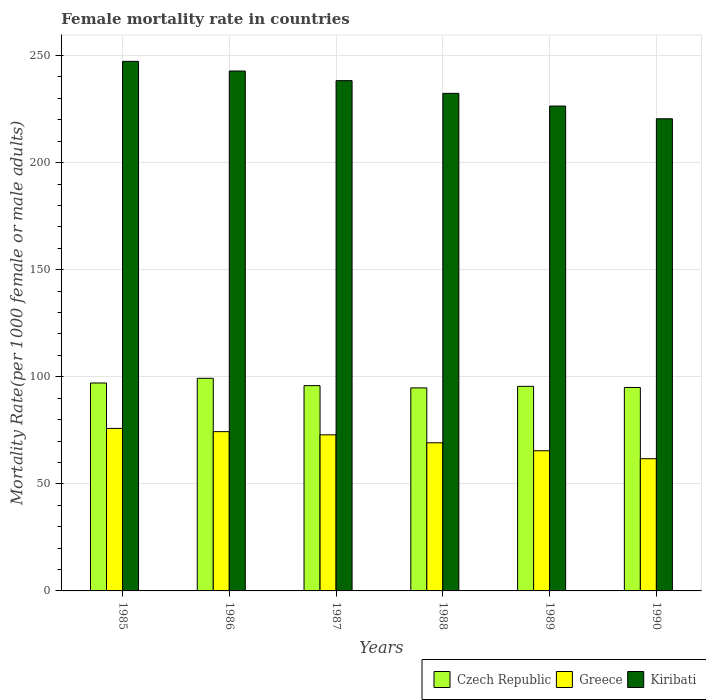How many different coloured bars are there?
Provide a succinct answer. 3. How many groups of bars are there?
Provide a short and direct response. 6. How many bars are there on the 4th tick from the left?
Your answer should be compact. 3. How many bars are there on the 3rd tick from the right?
Offer a terse response. 3. What is the female mortality rate in Greece in 1990?
Provide a succinct answer. 61.74. Across all years, what is the maximum female mortality rate in Kiribati?
Ensure brevity in your answer.  247.28. Across all years, what is the minimum female mortality rate in Greece?
Your answer should be very brief. 61.74. In which year was the female mortality rate in Greece maximum?
Offer a terse response. 1985. In which year was the female mortality rate in Kiribati minimum?
Offer a very short reply. 1990. What is the total female mortality rate in Greece in the graph?
Offer a very short reply. 419.49. What is the difference between the female mortality rate in Czech Republic in 1987 and that in 1989?
Give a very brief answer. 0.33. What is the difference between the female mortality rate in Czech Republic in 1988 and the female mortality rate in Kiribati in 1990?
Make the answer very short. -125.67. What is the average female mortality rate in Greece per year?
Offer a very short reply. 69.91. In the year 1985, what is the difference between the female mortality rate in Czech Republic and female mortality rate in Kiribati?
Your answer should be very brief. -150.19. What is the ratio of the female mortality rate in Greece in 1986 to that in 1989?
Offer a very short reply. 1.14. Is the female mortality rate in Greece in 1985 less than that in 1988?
Give a very brief answer. No. What is the difference between the highest and the second highest female mortality rate in Kiribati?
Offer a very short reply. 4.51. What is the difference between the highest and the lowest female mortality rate in Greece?
Offer a terse response. 14.14. In how many years, is the female mortality rate in Kiribati greater than the average female mortality rate in Kiribati taken over all years?
Your answer should be very brief. 3. Is the sum of the female mortality rate in Czech Republic in 1987 and 1990 greater than the maximum female mortality rate in Greece across all years?
Offer a terse response. Yes. What does the 3rd bar from the right in 1987 represents?
Offer a terse response. Czech Republic. Is it the case that in every year, the sum of the female mortality rate in Czech Republic and female mortality rate in Kiribati is greater than the female mortality rate in Greece?
Keep it short and to the point. Yes. How many bars are there?
Ensure brevity in your answer.  18. Are all the bars in the graph horizontal?
Your answer should be compact. No. How many years are there in the graph?
Offer a terse response. 6. What is the difference between two consecutive major ticks on the Y-axis?
Offer a terse response. 50. Are the values on the major ticks of Y-axis written in scientific E-notation?
Your response must be concise. No. Does the graph contain any zero values?
Give a very brief answer. No. Does the graph contain grids?
Provide a short and direct response. Yes. How are the legend labels stacked?
Provide a succinct answer. Horizontal. What is the title of the graph?
Your answer should be very brief. Female mortality rate in countries. Does "Cayman Islands" appear as one of the legend labels in the graph?
Provide a short and direct response. No. What is the label or title of the X-axis?
Give a very brief answer. Years. What is the label or title of the Y-axis?
Ensure brevity in your answer.  Mortality Rate(per 1000 female or male adults). What is the Mortality Rate(per 1000 female or male adults) of Czech Republic in 1985?
Keep it short and to the point. 97.09. What is the Mortality Rate(per 1000 female or male adults) of Greece in 1985?
Your answer should be very brief. 75.88. What is the Mortality Rate(per 1000 female or male adults) in Kiribati in 1985?
Give a very brief answer. 247.28. What is the Mortality Rate(per 1000 female or male adults) of Czech Republic in 1986?
Ensure brevity in your answer.  99.28. What is the Mortality Rate(per 1000 female or male adults) in Greece in 1986?
Make the answer very short. 74.38. What is the Mortality Rate(per 1000 female or male adults) in Kiribati in 1986?
Ensure brevity in your answer.  242.77. What is the Mortality Rate(per 1000 female or male adults) in Czech Republic in 1987?
Your answer should be very brief. 95.85. What is the Mortality Rate(per 1000 female or male adults) of Greece in 1987?
Provide a succinct answer. 72.88. What is the Mortality Rate(per 1000 female or male adults) in Kiribati in 1987?
Offer a very short reply. 238.26. What is the Mortality Rate(per 1000 female or male adults) in Czech Republic in 1988?
Offer a very short reply. 94.8. What is the Mortality Rate(per 1000 female or male adults) of Greece in 1988?
Ensure brevity in your answer.  69.17. What is the Mortality Rate(per 1000 female or male adults) in Kiribati in 1988?
Ensure brevity in your answer.  232.33. What is the Mortality Rate(per 1000 female or male adults) of Czech Republic in 1989?
Offer a very short reply. 95.52. What is the Mortality Rate(per 1000 female or male adults) of Greece in 1989?
Keep it short and to the point. 65.45. What is the Mortality Rate(per 1000 female or male adults) of Kiribati in 1989?
Give a very brief answer. 226.4. What is the Mortality Rate(per 1000 female or male adults) in Czech Republic in 1990?
Offer a very short reply. 95.01. What is the Mortality Rate(per 1000 female or male adults) of Greece in 1990?
Give a very brief answer. 61.74. What is the Mortality Rate(per 1000 female or male adults) of Kiribati in 1990?
Give a very brief answer. 220.47. Across all years, what is the maximum Mortality Rate(per 1000 female or male adults) in Czech Republic?
Ensure brevity in your answer.  99.28. Across all years, what is the maximum Mortality Rate(per 1000 female or male adults) in Greece?
Ensure brevity in your answer.  75.88. Across all years, what is the maximum Mortality Rate(per 1000 female or male adults) of Kiribati?
Offer a very short reply. 247.28. Across all years, what is the minimum Mortality Rate(per 1000 female or male adults) of Czech Republic?
Offer a terse response. 94.8. Across all years, what is the minimum Mortality Rate(per 1000 female or male adults) of Greece?
Your response must be concise. 61.74. Across all years, what is the minimum Mortality Rate(per 1000 female or male adults) in Kiribati?
Ensure brevity in your answer.  220.47. What is the total Mortality Rate(per 1000 female or male adults) in Czech Republic in the graph?
Offer a terse response. 577.55. What is the total Mortality Rate(per 1000 female or male adults) in Greece in the graph?
Offer a very short reply. 419.49. What is the total Mortality Rate(per 1000 female or male adults) of Kiribati in the graph?
Your answer should be very brief. 1407.51. What is the difference between the Mortality Rate(per 1000 female or male adults) in Czech Republic in 1985 and that in 1986?
Provide a succinct answer. -2.19. What is the difference between the Mortality Rate(per 1000 female or male adults) in Greece in 1985 and that in 1986?
Keep it short and to the point. 1.5. What is the difference between the Mortality Rate(per 1000 female or male adults) in Kiribati in 1985 and that in 1986?
Give a very brief answer. 4.51. What is the difference between the Mortality Rate(per 1000 female or male adults) of Czech Republic in 1985 and that in 1987?
Give a very brief answer. 1.23. What is the difference between the Mortality Rate(per 1000 female or male adults) of Greece in 1985 and that in 1987?
Your response must be concise. 3. What is the difference between the Mortality Rate(per 1000 female or male adults) in Kiribati in 1985 and that in 1987?
Your answer should be very brief. 9.01. What is the difference between the Mortality Rate(per 1000 female or male adults) of Czech Republic in 1985 and that in 1988?
Make the answer very short. 2.29. What is the difference between the Mortality Rate(per 1000 female or male adults) in Greece in 1985 and that in 1988?
Provide a short and direct response. 6.71. What is the difference between the Mortality Rate(per 1000 female or male adults) of Kiribati in 1985 and that in 1988?
Ensure brevity in your answer.  14.94. What is the difference between the Mortality Rate(per 1000 female or male adults) in Czech Republic in 1985 and that in 1989?
Your answer should be very brief. 1.56. What is the difference between the Mortality Rate(per 1000 female or male adults) of Greece in 1985 and that in 1989?
Offer a very short reply. 10.43. What is the difference between the Mortality Rate(per 1000 female or male adults) of Kiribati in 1985 and that in 1989?
Offer a very short reply. 20.88. What is the difference between the Mortality Rate(per 1000 female or male adults) in Czech Republic in 1985 and that in 1990?
Ensure brevity in your answer.  2.08. What is the difference between the Mortality Rate(per 1000 female or male adults) of Greece in 1985 and that in 1990?
Give a very brief answer. 14.14. What is the difference between the Mortality Rate(per 1000 female or male adults) in Kiribati in 1985 and that in 1990?
Provide a short and direct response. 26.81. What is the difference between the Mortality Rate(per 1000 female or male adults) in Czech Republic in 1986 and that in 1987?
Give a very brief answer. 3.43. What is the difference between the Mortality Rate(per 1000 female or male adults) of Greece in 1986 and that in 1987?
Provide a succinct answer. 1.5. What is the difference between the Mortality Rate(per 1000 female or male adults) in Kiribati in 1986 and that in 1987?
Give a very brief answer. 4.51. What is the difference between the Mortality Rate(per 1000 female or male adults) in Czech Republic in 1986 and that in 1988?
Make the answer very short. 4.48. What is the difference between the Mortality Rate(per 1000 female or male adults) of Greece in 1986 and that in 1988?
Ensure brevity in your answer.  5.21. What is the difference between the Mortality Rate(per 1000 female or male adults) of Kiribati in 1986 and that in 1988?
Provide a succinct answer. 10.44. What is the difference between the Mortality Rate(per 1000 female or male adults) in Czech Republic in 1986 and that in 1989?
Your response must be concise. 3.76. What is the difference between the Mortality Rate(per 1000 female or male adults) of Greece in 1986 and that in 1989?
Offer a terse response. 8.93. What is the difference between the Mortality Rate(per 1000 female or male adults) of Kiribati in 1986 and that in 1989?
Give a very brief answer. 16.37. What is the difference between the Mortality Rate(per 1000 female or male adults) in Czech Republic in 1986 and that in 1990?
Offer a very short reply. 4.27. What is the difference between the Mortality Rate(per 1000 female or male adults) in Greece in 1986 and that in 1990?
Provide a succinct answer. 12.64. What is the difference between the Mortality Rate(per 1000 female or male adults) of Kiribati in 1986 and that in 1990?
Keep it short and to the point. 22.3. What is the difference between the Mortality Rate(per 1000 female or male adults) in Czech Republic in 1987 and that in 1988?
Offer a very short reply. 1.05. What is the difference between the Mortality Rate(per 1000 female or male adults) in Greece in 1987 and that in 1988?
Make the answer very short. 3.71. What is the difference between the Mortality Rate(per 1000 female or male adults) in Kiribati in 1987 and that in 1988?
Your response must be concise. 5.93. What is the difference between the Mortality Rate(per 1000 female or male adults) in Czech Republic in 1987 and that in 1989?
Give a very brief answer. 0.33. What is the difference between the Mortality Rate(per 1000 female or male adults) of Greece in 1987 and that in 1989?
Your response must be concise. 7.43. What is the difference between the Mortality Rate(per 1000 female or male adults) in Kiribati in 1987 and that in 1989?
Your response must be concise. 11.86. What is the difference between the Mortality Rate(per 1000 female or male adults) of Czech Republic in 1987 and that in 1990?
Offer a very short reply. 0.85. What is the difference between the Mortality Rate(per 1000 female or male adults) in Greece in 1987 and that in 1990?
Provide a succinct answer. 11.14. What is the difference between the Mortality Rate(per 1000 female or male adults) of Kiribati in 1987 and that in 1990?
Offer a very short reply. 17.79. What is the difference between the Mortality Rate(per 1000 female or male adults) of Czech Republic in 1988 and that in 1989?
Provide a succinct answer. -0.72. What is the difference between the Mortality Rate(per 1000 female or male adults) of Greece in 1988 and that in 1989?
Provide a short and direct response. 3.71. What is the difference between the Mortality Rate(per 1000 female or male adults) of Kiribati in 1988 and that in 1989?
Keep it short and to the point. 5.93. What is the difference between the Mortality Rate(per 1000 female or male adults) in Czech Republic in 1988 and that in 1990?
Keep it short and to the point. -0.21. What is the difference between the Mortality Rate(per 1000 female or male adults) in Greece in 1988 and that in 1990?
Your answer should be compact. 7.43. What is the difference between the Mortality Rate(per 1000 female or male adults) in Kiribati in 1988 and that in 1990?
Give a very brief answer. 11.86. What is the difference between the Mortality Rate(per 1000 female or male adults) in Czech Republic in 1989 and that in 1990?
Provide a succinct answer. 0.52. What is the difference between the Mortality Rate(per 1000 female or male adults) in Greece in 1989 and that in 1990?
Keep it short and to the point. 3.71. What is the difference between the Mortality Rate(per 1000 female or male adults) of Kiribati in 1989 and that in 1990?
Provide a short and direct response. 5.93. What is the difference between the Mortality Rate(per 1000 female or male adults) of Czech Republic in 1985 and the Mortality Rate(per 1000 female or male adults) of Greece in 1986?
Keep it short and to the point. 22.71. What is the difference between the Mortality Rate(per 1000 female or male adults) of Czech Republic in 1985 and the Mortality Rate(per 1000 female or male adults) of Kiribati in 1986?
Ensure brevity in your answer.  -145.68. What is the difference between the Mortality Rate(per 1000 female or male adults) in Greece in 1985 and the Mortality Rate(per 1000 female or male adults) in Kiribati in 1986?
Provide a succinct answer. -166.89. What is the difference between the Mortality Rate(per 1000 female or male adults) of Czech Republic in 1985 and the Mortality Rate(per 1000 female or male adults) of Greece in 1987?
Provide a short and direct response. 24.21. What is the difference between the Mortality Rate(per 1000 female or male adults) of Czech Republic in 1985 and the Mortality Rate(per 1000 female or male adults) of Kiribati in 1987?
Provide a short and direct response. -141.18. What is the difference between the Mortality Rate(per 1000 female or male adults) in Greece in 1985 and the Mortality Rate(per 1000 female or male adults) in Kiribati in 1987?
Your answer should be very brief. -162.38. What is the difference between the Mortality Rate(per 1000 female or male adults) of Czech Republic in 1985 and the Mortality Rate(per 1000 female or male adults) of Greece in 1988?
Keep it short and to the point. 27.92. What is the difference between the Mortality Rate(per 1000 female or male adults) in Czech Republic in 1985 and the Mortality Rate(per 1000 female or male adults) in Kiribati in 1988?
Offer a terse response. -135.25. What is the difference between the Mortality Rate(per 1000 female or male adults) of Greece in 1985 and the Mortality Rate(per 1000 female or male adults) of Kiribati in 1988?
Provide a succinct answer. -156.45. What is the difference between the Mortality Rate(per 1000 female or male adults) in Czech Republic in 1985 and the Mortality Rate(per 1000 female or male adults) in Greece in 1989?
Your response must be concise. 31.64. What is the difference between the Mortality Rate(per 1000 female or male adults) of Czech Republic in 1985 and the Mortality Rate(per 1000 female or male adults) of Kiribati in 1989?
Make the answer very short. -129.31. What is the difference between the Mortality Rate(per 1000 female or male adults) of Greece in 1985 and the Mortality Rate(per 1000 female or male adults) of Kiribati in 1989?
Make the answer very short. -150.52. What is the difference between the Mortality Rate(per 1000 female or male adults) of Czech Republic in 1985 and the Mortality Rate(per 1000 female or male adults) of Greece in 1990?
Give a very brief answer. 35.35. What is the difference between the Mortality Rate(per 1000 female or male adults) in Czech Republic in 1985 and the Mortality Rate(per 1000 female or male adults) in Kiribati in 1990?
Your answer should be compact. -123.38. What is the difference between the Mortality Rate(per 1000 female or male adults) of Greece in 1985 and the Mortality Rate(per 1000 female or male adults) of Kiribati in 1990?
Offer a terse response. -144.59. What is the difference between the Mortality Rate(per 1000 female or male adults) of Czech Republic in 1986 and the Mortality Rate(per 1000 female or male adults) of Greece in 1987?
Keep it short and to the point. 26.4. What is the difference between the Mortality Rate(per 1000 female or male adults) in Czech Republic in 1986 and the Mortality Rate(per 1000 female or male adults) in Kiribati in 1987?
Ensure brevity in your answer.  -138.98. What is the difference between the Mortality Rate(per 1000 female or male adults) in Greece in 1986 and the Mortality Rate(per 1000 female or male adults) in Kiribati in 1987?
Offer a terse response. -163.88. What is the difference between the Mortality Rate(per 1000 female or male adults) of Czech Republic in 1986 and the Mortality Rate(per 1000 female or male adults) of Greece in 1988?
Your answer should be very brief. 30.12. What is the difference between the Mortality Rate(per 1000 female or male adults) of Czech Republic in 1986 and the Mortality Rate(per 1000 female or male adults) of Kiribati in 1988?
Provide a succinct answer. -133.05. What is the difference between the Mortality Rate(per 1000 female or male adults) of Greece in 1986 and the Mortality Rate(per 1000 female or male adults) of Kiribati in 1988?
Your answer should be very brief. -157.95. What is the difference between the Mortality Rate(per 1000 female or male adults) of Czech Republic in 1986 and the Mortality Rate(per 1000 female or male adults) of Greece in 1989?
Offer a very short reply. 33.83. What is the difference between the Mortality Rate(per 1000 female or male adults) in Czech Republic in 1986 and the Mortality Rate(per 1000 female or male adults) in Kiribati in 1989?
Provide a short and direct response. -127.12. What is the difference between the Mortality Rate(per 1000 female or male adults) in Greece in 1986 and the Mortality Rate(per 1000 female or male adults) in Kiribati in 1989?
Provide a succinct answer. -152.02. What is the difference between the Mortality Rate(per 1000 female or male adults) in Czech Republic in 1986 and the Mortality Rate(per 1000 female or male adults) in Greece in 1990?
Ensure brevity in your answer.  37.55. What is the difference between the Mortality Rate(per 1000 female or male adults) in Czech Republic in 1986 and the Mortality Rate(per 1000 female or male adults) in Kiribati in 1990?
Provide a succinct answer. -121.19. What is the difference between the Mortality Rate(per 1000 female or male adults) in Greece in 1986 and the Mortality Rate(per 1000 female or male adults) in Kiribati in 1990?
Provide a succinct answer. -146.09. What is the difference between the Mortality Rate(per 1000 female or male adults) of Czech Republic in 1987 and the Mortality Rate(per 1000 female or male adults) of Greece in 1988?
Your answer should be very brief. 26.69. What is the difference between the Mortality Rate(per 1000 female or male adults) of Czech Republic in 1987 and the Mortality Rate(per 1000 female or male adults) of Kiribati in 1988?
Your answer should be very brief. -136.48. What is the difference between the Mortality Rate(per 1000 female or male adults) in Greece in 1987 and the Mortality Rate(per 1000 female or male adults) in Kiribati in 1988?
Give a very brief answer. -159.45. What is the difference between the Mortality Rate(per 1000 female or male adults) of Czech Republic in 1987 and the Mortality Rate(per 1000 female or male adults) of Greece in 1989?
Offer a very short reply. 30.4. What is the difference between the Mortality Rate(per 1000 female or male adults) of Czech Republic in 1987 and the Mortality Rate(per 1000 female or male adults) of Kiribati in 1989?
Offer a very short reply. -130.55. What is the difference between the Mortality Rate(per 1000 female or male adults) in Greece in 1987 and the Mortality Rate(per 1000 female or male adults) in Kiribati in 1989?
Make the answer very short. -153.52. What is the difference between the Mortality Rate(per 1000 female or male adults) in Czech Republic in 1987 and the Mortality Rate(per 1000 female or male adults) in Greece in 1990?
Provide a short and direct response. 34.12. What is the difference between the Mortality Rate(per 1000 female or male adults) in Czech Republic in 1987 and the Mortality Rate(per 1000 female or male adults) in Kiribati in 1990?
Keep it short and to the point. -124.62. What is the difference between the Mortality Rate(per 1000 female or male adults) in Greece in 1987 and the Mortality Rate(per 1000 female or male adults) in Kiribati in 1990?
Your answer should be very brief. -147.59. What is the difference between the Mortality Rate(per 1000 female or male adults) in Czech Republic in 1988 and the Mortality Rate(per 1000 female or male adults) in Greece in 1989?
Keep it short and to the point. 29.35. What is the difference between the Mortality Rate(per 1000 female or male adults) of Czech Republic in 1988 and the Mortality Rate(per 1000 female or male adults) of Kiribati in 1989?
Ensure brevity in your answer.  -131.6. What is the difference between the Mortality Rate(per 1000 female or male adults) of Greece in 1988 and the Mortality Rate(per 1000 female or male adults) of Kiribati in 1989?
Give a very brief answer. -157.24. What is the difference between the Mortality Rate(per 1000 female or male adults) of Czech Republic in 1988 and the Mortality Rate(per 1000 female or male adults) of Greece in 1990?
Your answer should be very brief. 33.06. What is the difference between the Mortality Rate(per 1000 female or male adults) in Czech Republic in 1988 and the Mortality Rate(per 1000 female or male adults) in Kiribati in 1990?
Keep it short and to the point. -125.67. What is the difference between the Mortality Rate(per 1000 female or male adults) in Greece in 1988 and the Mortality Rate(per 1000 female or male adults) in Kiribati in 1990?
Offer a very short reply. -151.3. What is the difference between the Mortality Rate(per 1000 female or male adults) in Czech Republic in 1989 and the Mortality Rate(per 1000 female or male adults) in Greece in 1990?
Offer a terse response. 33.79. What is the difference between the Mortality Rate(per 1000 female or male adults) of Czech Republic in 1989 and the Mortality Rate(per 1000 female or male adults) of Kiribati in 1990?
Your response must be concise. -124.95. What is the difference between the Mortality Rate(per 1000 female or male adults) of Greece in 1989 and the Mortality Rate(per 1000 female or male adults) of Kiribati in 1990?
Provide a short and direct response. -155.02. What is the average Mortality Rate(per 1000 female or male adults) in Czech Republic per year?
Provide a succinct answer. 96.26. What is the average Mortality Rate(per 1000 female or male adults) in Greece per year?
Offer a terse response. 69.91. What is the average Mortality Rate(per 1000 female or male adults) in Kiribati per year?
Ensure brevity in your answer.  234.59. In the year 1985, what is the difference between the Mortality Rate(per 1000 female or male adults) in Czech Republic and Mortality Rate(per 1000 female or male adults) in Greece?
Make the answer very short. 21.21. In the year 1985, what is the difference between the Mortality Rate(per 1000 female or male adults) of Czech Republic and Mortality Rate(per 1000 female or male adults) of Kiribati?
Ensure brevity in your answer.  -150.19. In the year 1985, what is the difference between the Mortality Rate(per 1000 female or male adults) of Greece and Mortality Rate(per 1000 female or male adults) of Kiribati?
Your answer should be very brief. -171.4. In the year 1986, what is the difference between the Mortality Rate(per 1000 female or male adults) in Czech Republic and Mortality Rate(per 1000 female or male adults) in Greece?
Give a very brief answer. 24.9. In the year 1986, what is the difference between the Mortality Rate(per 1000 female or male adults) of Czech Republic and Mortality Rate(per 1000 female or male adults) of Kiribati?
Offer a very short reply. -143.49. In the year 1986, what is the difference between the Mortality Rate(per 1000 female or male adults) in Greece and Mortality Rate(per 1000 female or male adults) in Kiribati?
Your answer should be very brief. -168.39. In the year 1987, what is the difference between the Mortality Rate(per 1000 female or male adults) in Czech Republic and Mortality Rate(per 1000 female or male adults) in Greece?
Your answer should be compact. 22.97. In the year 1987, what is the difference between the Mortality Rate(per 1000 female or male adults) in Czech Republic and Mortality Rate(per 1000 female or male adults) in Kiribati?
Ensure brevity in your answer.  -142.41. In the year 1987, what is the difference between the Mortality Rate(per 1000 female or male adults) in Greece and Mortality Rate(per 1000 female or male adults) in Kiribati?
Give a very brief answer. -165.38. In the year 1988, what is the difference between the Mortality Rate(per 1000 female or male adults) of Czech Republic and Mortality Rate(per 1000 female or male adults) of Greece?
Keep it short and to the point. 25.63. In the year 1988, what is the difference between the Mortality Rate(per 1000 female or male adults) of Czech Republic and Mortality Rate(per 1000 female or male adults) of Kiribati?
Ensure brevity in your answer.  -137.53. In the year 1988, what is the difference between the Mortality Rate(per 1000 female or male adults) in Greece and Mortality Rate(per 1000 female or male adults) in Kiribati?
Ensure brevity in your answer.  -163.17. In the year 1989, what is the difference between the Mortality Rate(per 1000 female or male adults) of Czech Republic and Mortality Rate(per 1000 female or male adults) of Greece?
Your answer should be very brief. 30.07. In the year 1989, what is the difference between the Mortality Rate(per 1000 female or male adults) in Czech Republic and Mortality Rate(per 1000 female or male adults) in Kiribati?
Make the answer very short. -130.88. In the year 1989, what is the difference between the Mortality Rate(per 1000 female or male adults) in Greece and Mortality Rate(per 1000 female or male adults) in Kiribati?
Your answer should be compact. -160.95. In the year 1990, what is the difference between the Mortality Rate(per 1000 female or male adults) of Czech Republic and Mortality Rate(per 1000 female or male adults) of Greece?
Keep it short and to the point. 33.27. In the year 1990, what is the difference between the Mortality Rate(per 1000 female or male adults) in Czech Republic and Mortality Rate(per 1000 female or male adults) in Kiribati?
Keep it short and to the point. -125.46. In the year 1990, what is the difference between the Mortality Rate(per 1000 female or male adults) of Greece and Mortality Rate(per 1000 female or male adults) of Kiribati?
Offer a very short reply. -158.73. What is the ratio of the Mortality Rate(per 1000 female or male adults) of Czech Republic in 1985 to that in 1986?
Make the answer very short. 0.98. What is the ratio of the Mortality Rate(per 1000 female or male adults) of Greece in 1985 to that in 1986?
Your answer should be very brief. 1.02. What is the ratio of the Mortality Rate(per 1000 female or male adults) of Kiribati in 1985 to that in 1986?
Make the answer very short. 1.02. What is the ratio of the Mortality Rate(per 1000 female or male adults) of Czech Republic in 1985 to that in 1987?
Your response must be concise. 1.01. What is the ratio of the Mortality Rate(per 1000 female or male adults) in Greece in 1985 to that in 1987?
Your answer should be very brief. 1.04. What is the ratio of the Mortality Rate(per 1000 female or male adults) in Kiribati in 1985 to that in 1987?
Provide a short and direct response. 1.04. What is the ratio of the Mortality Rate(per 1000 female or male adults) of Czech Republic in 1985 to that in 1988?
Your answer should be very brief. 1.02. What is the ratio of the Mortality Rate(per 1000 female or male adults) in Greece in 1985 to that in 1988?
Provide a succinct answer. 1.1. What is the ratio of the Mortality Rate(per 1000 female or male adults) in Kiribati in 1985 to that in 1988?
Offer a very short reply. 1.06. What is the ratio of the Mortality Rate(per 1000 female or male adults) of Czech Republic in 1985 to that in 1989?
Provide a succinct answer. 1.02. What is the ratio of the Mortality Rate(per 1000 female or male adults) of Greece in 1985 to that in 1989?
Offer a terse response. 1.16. What is the ratio of the Mortality Rate(per 1000 female or male adults) in Kiribati in 1985 to that in 1989?
Provide a succinct answer. 1.09. What is the ratio of the Mortality Rate(per 1000 female or male adults) in Czech Republic in 1985 to that in 1990?
Make the answer very short. 1.02. What is the ratio of the Mortality Rate(per 1000 female or male adults) in Greece in 1985 to that in 1990?
Your answer should be very brief. 1.23. What is the ratio of the Mortality Rate(per 1000 female or male adults) of Kiribati in 1985 to that in 1990?
Ensure brevity in your answer.  1.12. What is the ratio of the Mortality Rate(per 1000 female or male adults) of Czech Republic in 1986 to that in 1987?
Your answer should be very brief. 1.04. What is the ratio of the Mortality Rate(per 1000 female or male adults) of Greece in 1986 to that in 1987?
Give a very brief answer. 1.02. What is the ratio of the Mortality Rate(per 1000 female or male adults) of Kiribati in 1986 to that in 1987?
Ensure brevity in your answer.  1.02. What is the ratio of the Mortality Rate(per 1000 female or male adults) in Czech Republic in 1986 to that in 1988?
Give a very brief answer. 1.05. What is the ratio of the Mortality Rate(per 1000 female or male adults) in Greece in 1986 to that in 1988?
Your answer should be very brief. 1.08. What is the ratio of the Mortality Rate(per 1000 female or male adults) in Kiribati in 1986 to that in 1988?
Keep it short and to the point. 1.04. What is the ratio of the Mortality Rate(per 1000 female or male adults) in Czech Republic in 1986 to that in 1989?
Keep it short and to the point. 1.04. What is the ratio of the Mortality Rate(per 1000 female or male adults) of Greece in 1986 to that in 1989?
Give a very brief answer. 1.14. What is the ratio of the Mortality Rate(per 1000 female or male adults) in Kiribati in 1986 to that in 1989?
Provide a succinct answer. 1.07. What is the ratio of the Mortality Rate(per 1000 female or male adults) in Czech Republic in 1986 to that in 1990?
Ensure brevity in your answer.  1.04. What is the ratio of the Mortality Rate(per 1000 female or male adults) in Greece in 1986 to that in 1990?
Offer a very short reply. 1.2. What is the ratio of the Mortality Rate(per 1000 female or male adults) in Kiribati in 1986 to that in 1990?
Your answer should be very brief. 1.1. What is the ratio of the Mortality Rate(per 1000 female or male adults) in Czech Republic in 1987 to that in 1988?
Your response must be concise. 1.01. What is the ratio of the Mortality Rate(per 1000 female or male adults) in Greece in 1987 to that in 1988?
Your response must be concise. 1.05. What is the ratio of the Mortality Rate(per 1000 female or male adults) in Kiribati in 1987 to that in 1988?
Keep it short and to the point. 1.03. What is the ratio of the Mortality Rate(per 1000 female or male adults) of Czech Republic in 1987 to that in 1989?
Offer a terse response. 1. What is the ratio of the Mortality Rate(per 1000 female or male adults) of Greece in 1987 to that in 1989?
Provide a short and direct response. 1.11. What is the ratio of the Mortality Rate(per 1000 female or male adults) in Kiribati in 1987 to that in 1989?
Your response must be concise. 1.05. What is the ratio of the Mortality Rate(per 1000 female or male adults) of Czech Republic in 1987 to that in 1990?
Offer a terse response. 1.01. What is the ratio of the Mortality Rate(per 1000 female or male adults) of Greece in 1987 to that in 1990?
Your answer should be compact. 1.18. What is the ratio of the Mortality Rate(per 1000 female or male adults) in Kiribati in 1987 to that in 1990?
Keep it short and to the point. 1.08. What is the ratio of the Mortality Rate(per 1000 female or male adults) in Czech Republic in 1988 to that in 1989?
Make the answer very short. 0.99. What is the ratio of the Mortality Rate(per 1000 female or male adults) of Greece in 1988 to that in 1989?
Keep it short and to the point. 1.06. What is the ratio of the Mortality Rate(per 1000 female or male adults) of Kiribati in 1988 to that in 1989?
Ensure brevity in your answer.  1.03. What is the ratio of the Mortality Rate(per 1000 female or male adults) of Greece in 1988 to that in 1990?
Your answer should be compact. 1.12. What is the ratio of the Mortality Rate(per 1000 female or male adults) in Kiribati in 1988 to that in 1990?
Ensure brevity in your answer.  1.05. What is the ratio of the Mortality Rate(per 1000 female or male adults) in Czech Republic in 1989 to that in 1990?
Provide a short and direct response. 1.01. What is the ratio of the Mortality Rate(per 1000 female or male adults) in Greece in 1989 to that in 1990?
Keep it short and to the point. 1.06. What is the ratio of the Mortality Rate(per 1000 female or male adults) of Kiribati in 1989 to that in 1990?
Offer a terse response. 1.03. What is the difference between the highest and the second highest Mortality Rate(per 1000 female or male adults) of Czech Republic?
Keep it short and to the point. 2.19. What is the difference between the highest and the second highest Mortality Rate(per 1000 female or male adults) in Greece?
Your answer should be compact. 1.5. What is the difference between the highest and the second highest Mortality Rate(per 1000 female or male adults) in Kiribati?
Keep it short and to the point. 4.51. What is the difference between the highest and the lowest Mortality Rate(per 1000 female or male adults) of Czech Republic?
Your response must be concise. 4.48. What is the difference between the highest and the lowest Mortality Rate(per 1000 female or male adults) in Greece?
Provide a succinct answer. 14.14. What is the difference between the highest and the lowest Mortality Rate(per 1000 female or male adults) in Kiribati?
Your answer should be very brief. 26.81. 